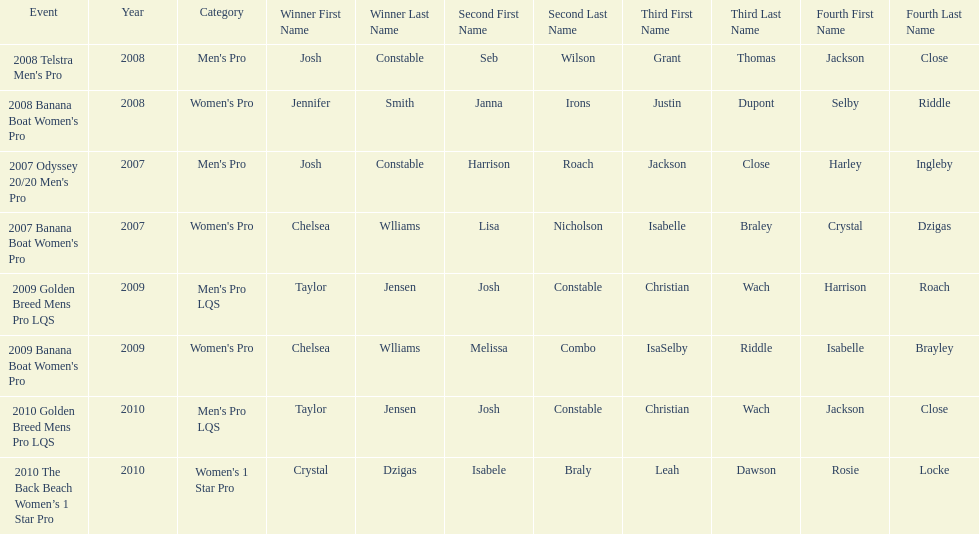In what event did chelsea williams win her first title? 2007 Banana Boat Women's Pro. 